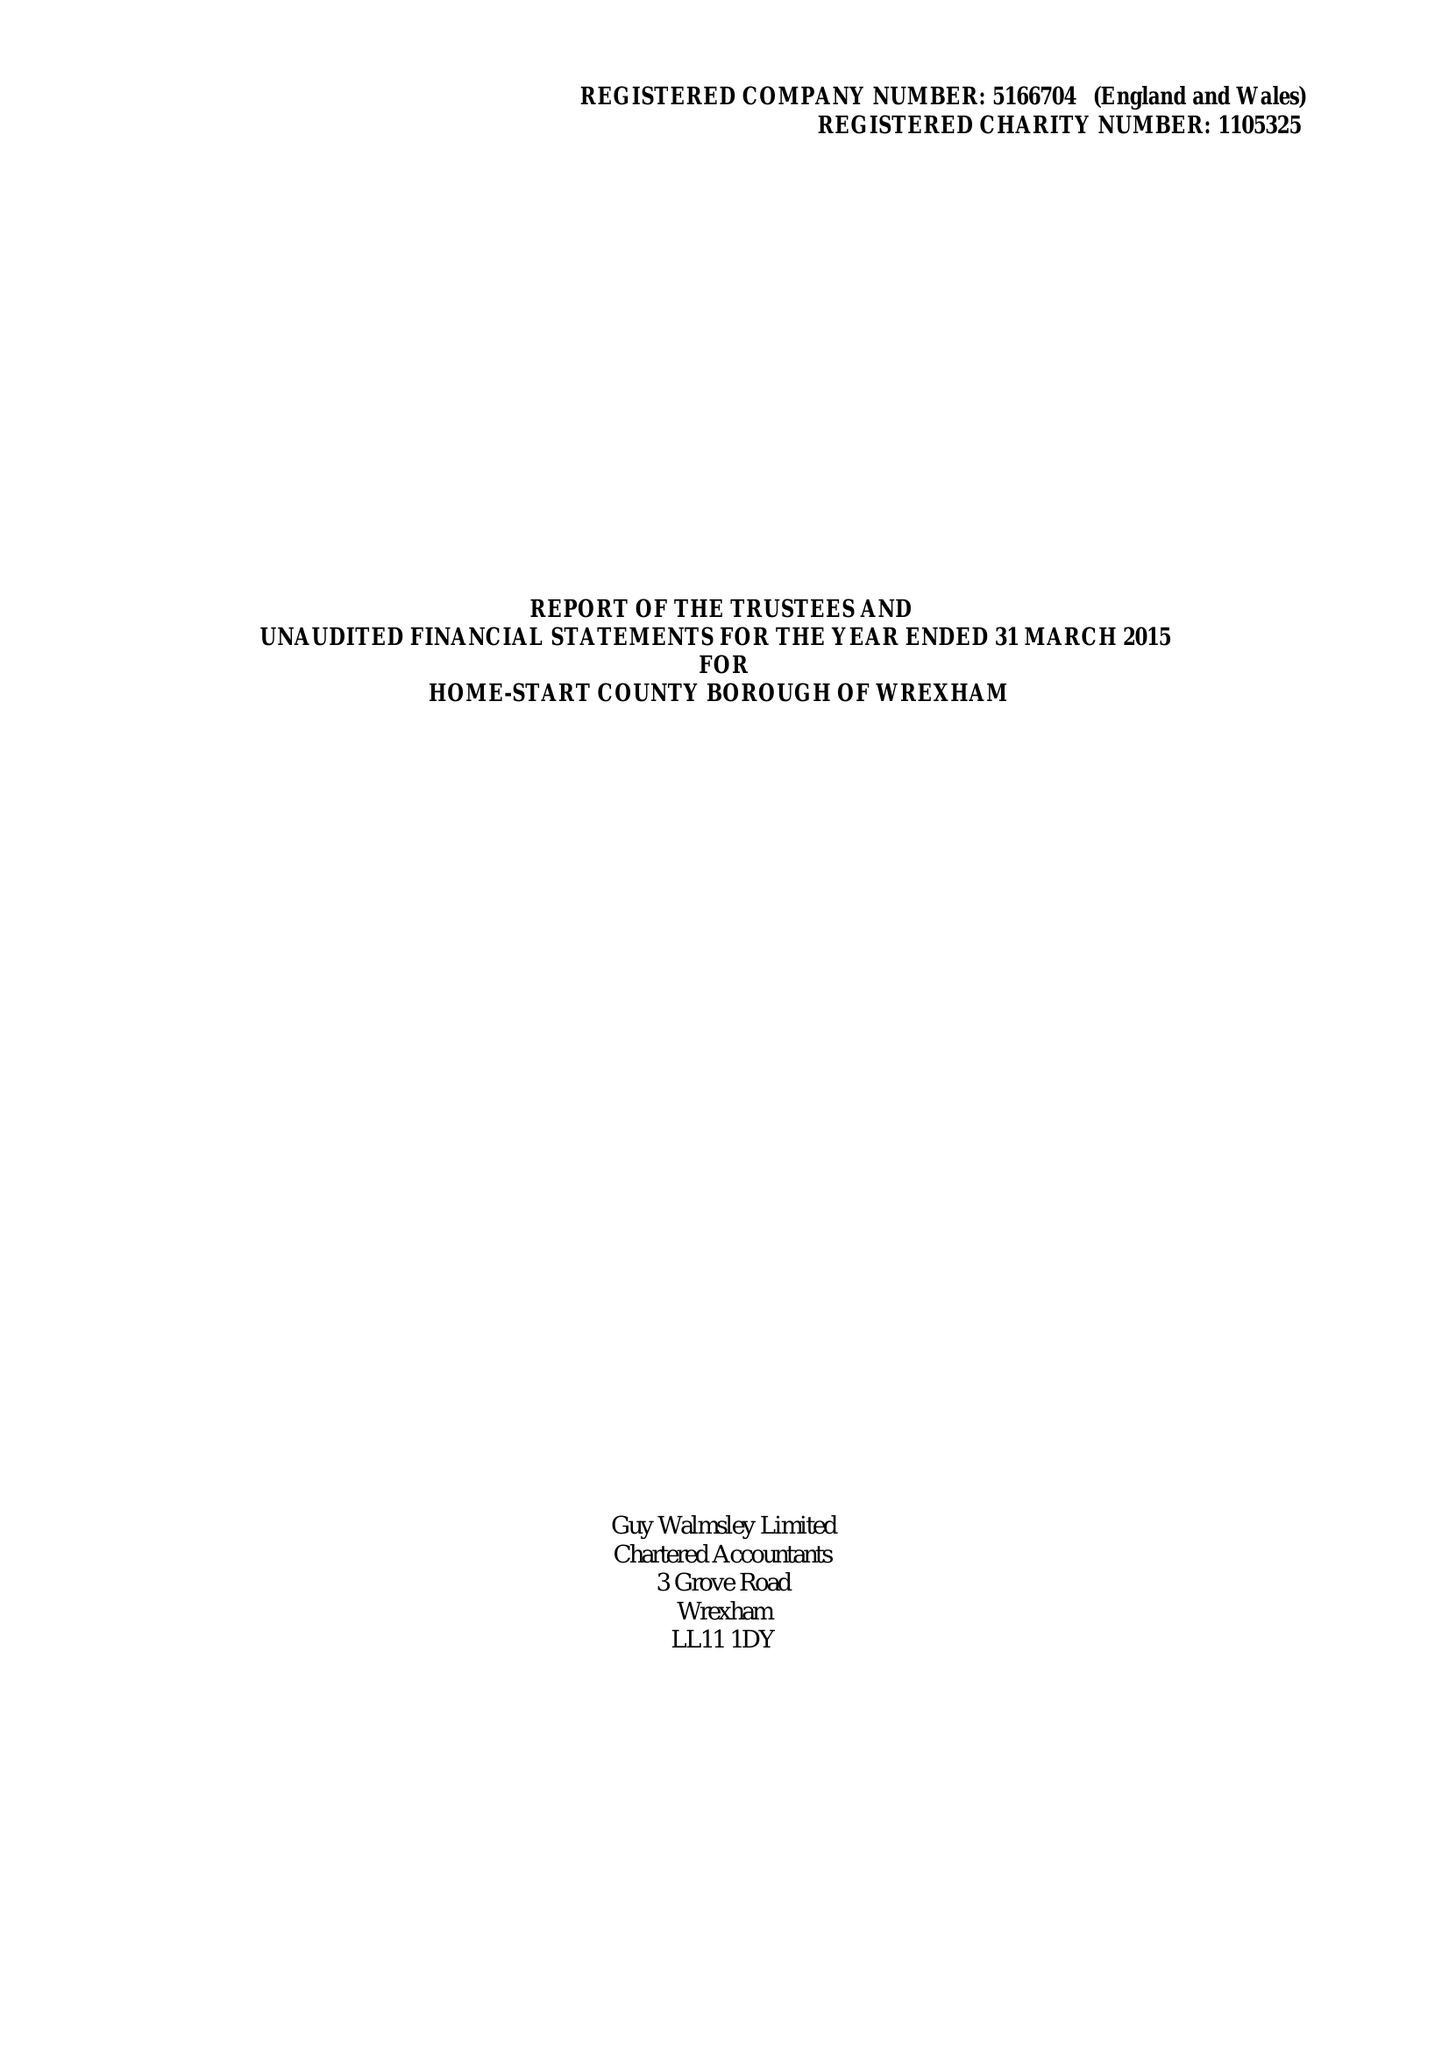What is the value for the address__postcode?
Answer the question using a single word or phrase. LL11 2NU 